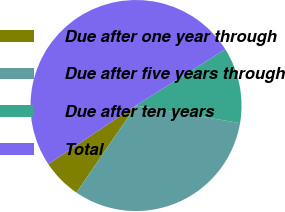Convert chart. <chart><loc_0><loc_0><loc_500><loc_500><pie_chart><fcel>Due after one year through<fcel>Due after five years through<fcel>Due after ten years<fcel>Total<nl><fcel>6.07%<fcel>31.89%<fcel>11.62%<fcel>50.42%<nl></chart> 